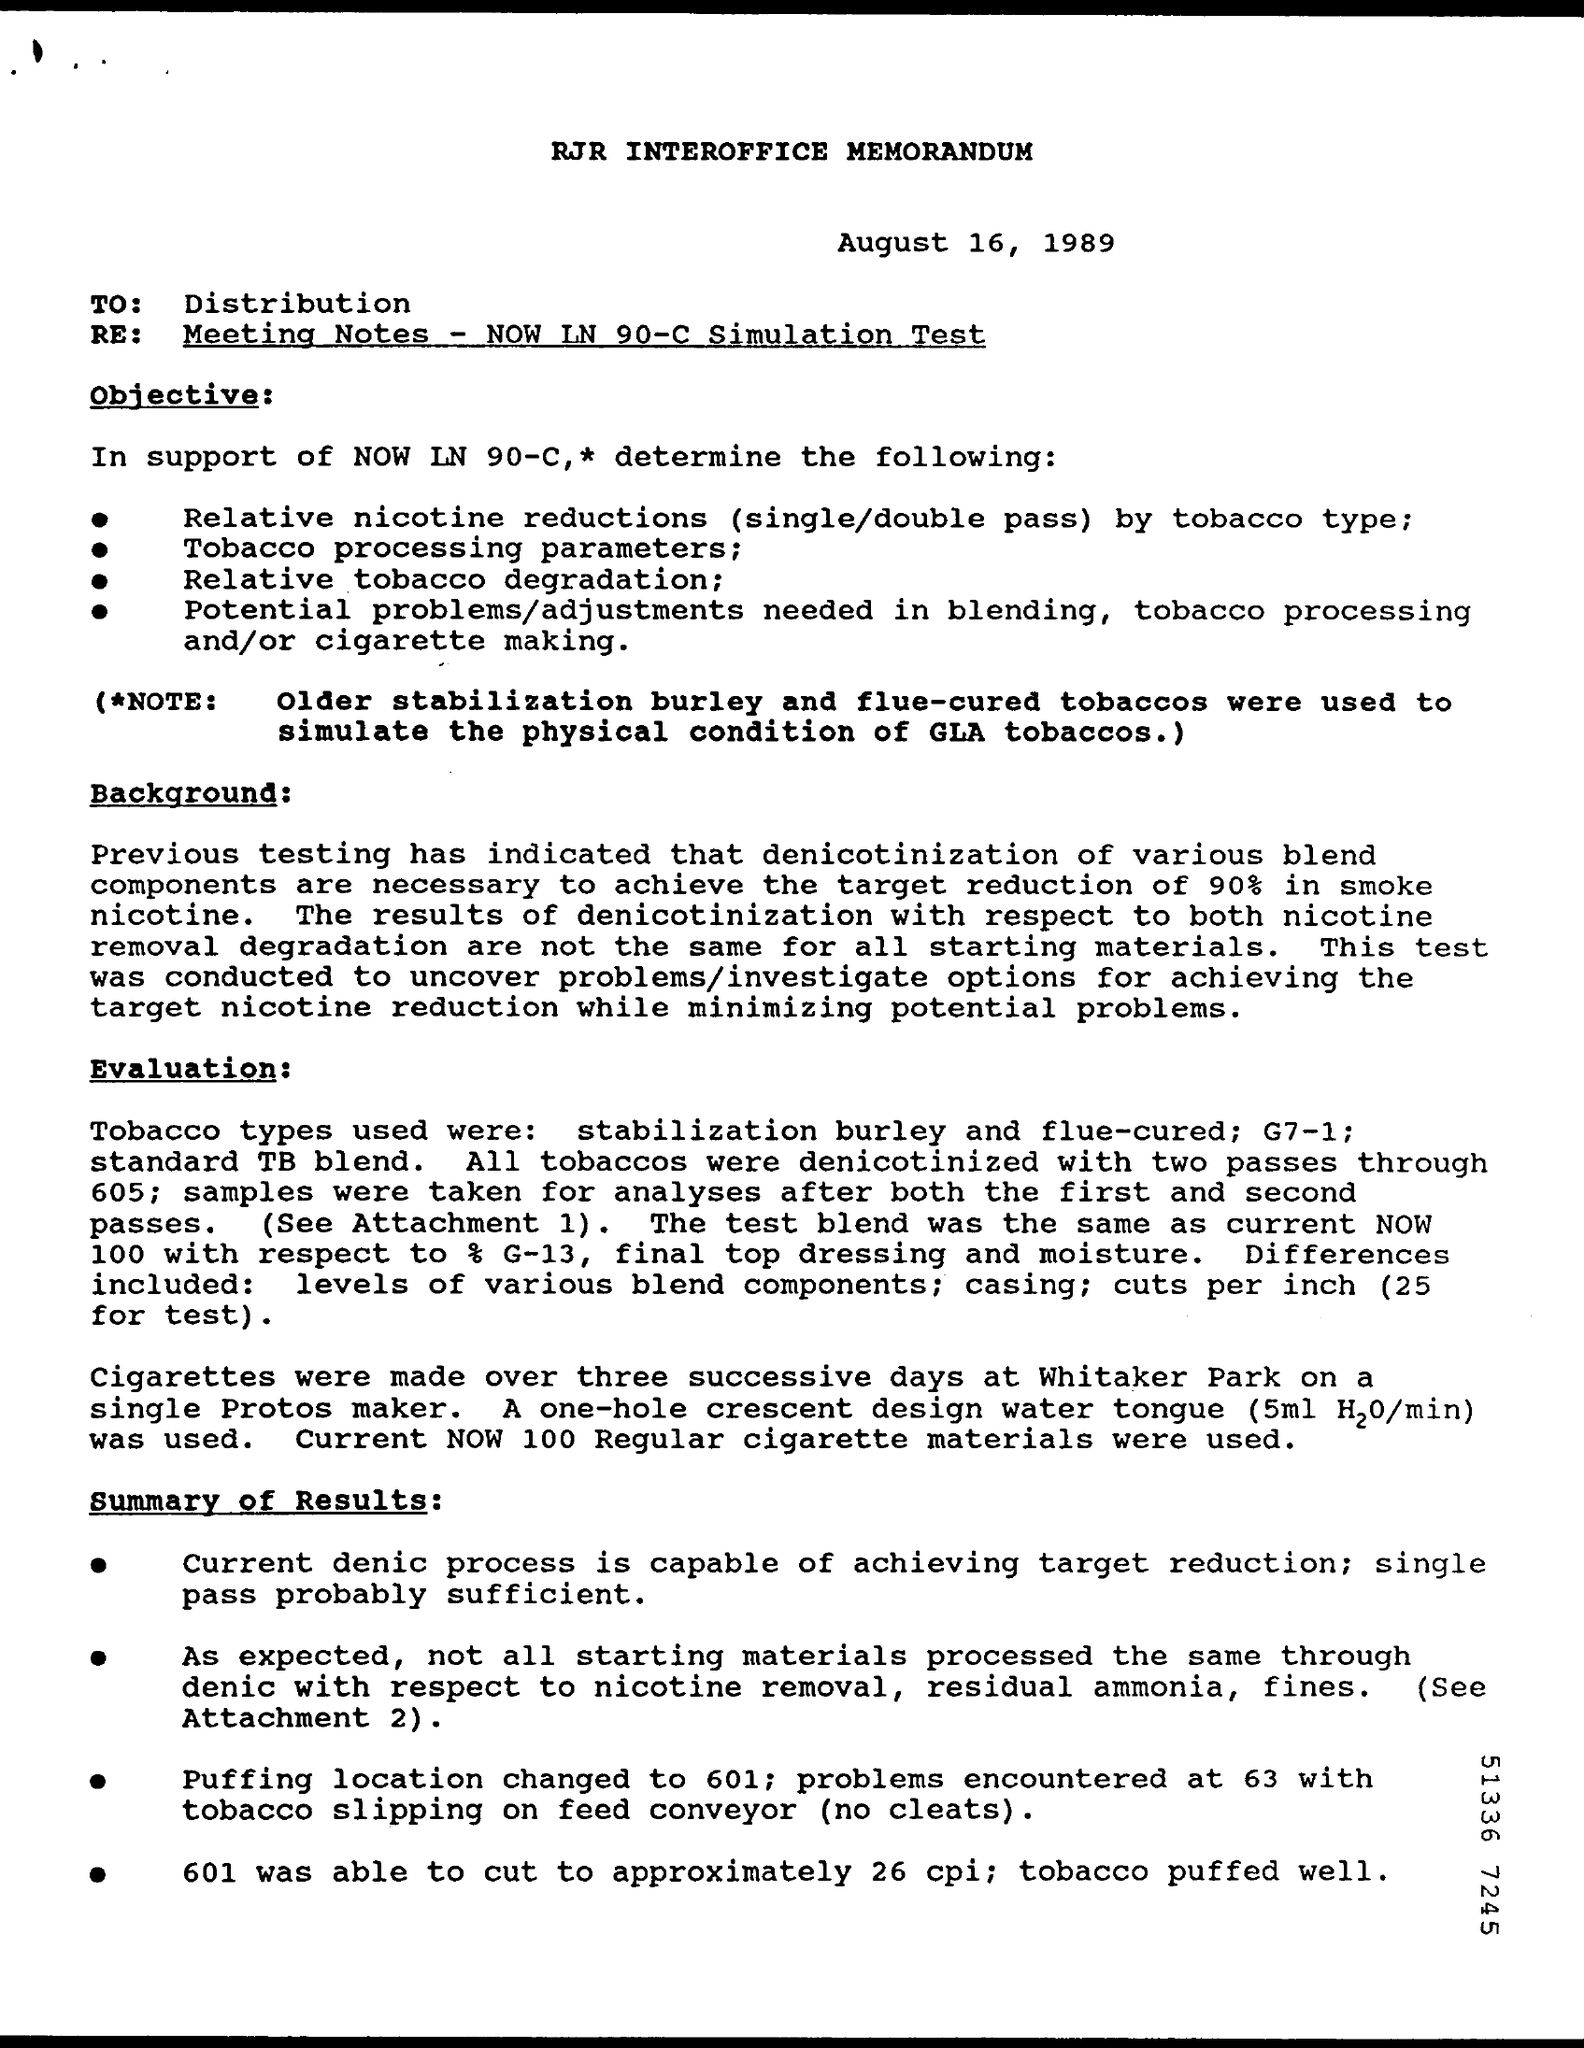Outline some significant characteristics in this image. The memorandum indicates that the date is August 16, 1989. This memorandum is addressed to the distribution list. 